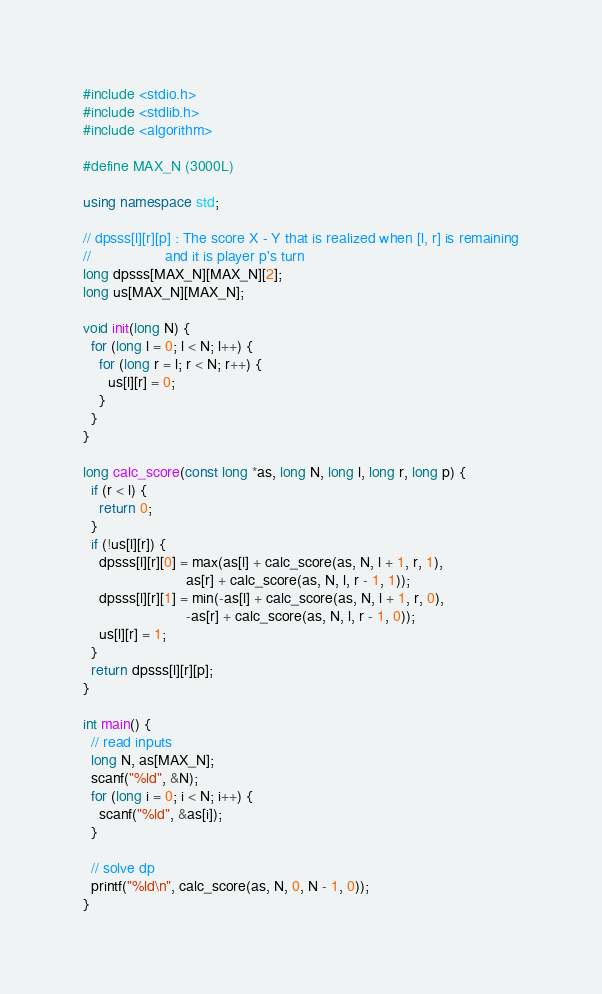<code> <loc_0><loc_0><loc_500><loc_500><_C++_>#include <stdio.h>
#include <stdlib.h>
#include <algorithm>

#define MAX_N (3000L)

using namespace std;

// dpsss[l][r][p] : The score X - Y that is realized when [l, r] is remaining
//                  and it is player p's turn
long dpsss[MAX_N][MAX_N][2];
long us[MAX_N][MAX_N];

void init(long N) {
  for (long l = 0; l < N; l++) {
    for (long r = l; r < N; r++) {
      us[l][r] = 0;
    }
  }
}

long calc_score(const long *as, long N, long l, long r, long p) {
  if (r < l) {
    return 0;
  }
  if (!us[l][r]) {
    dpsss[l][r][0] = max(as[l] + calc_score(as, N, l + 1, r, 1),
                         as[r] + calc_score(as, N, l, r - 1, 1));
    dpsss[l][r][1] = min(-as[l] + calc_score(as, N, l + 1, r, 0),
                         -as[r] + calc_score(as, N, l, r - 1, 0));
    us[l][r] = 1;
  }
  return dpsss[l][r][p];
}

int main() {
  // read inputs
  long N, as[MAX_N];
  scanf("%ld", &N);
  for (long i = 0; i < N; i++) {
    scanf("%ld", &as[i]);
  }

  // solve dp
  printf("%ld\n", calc_score(as, N, 0, N - 1, 0));
}</code> 